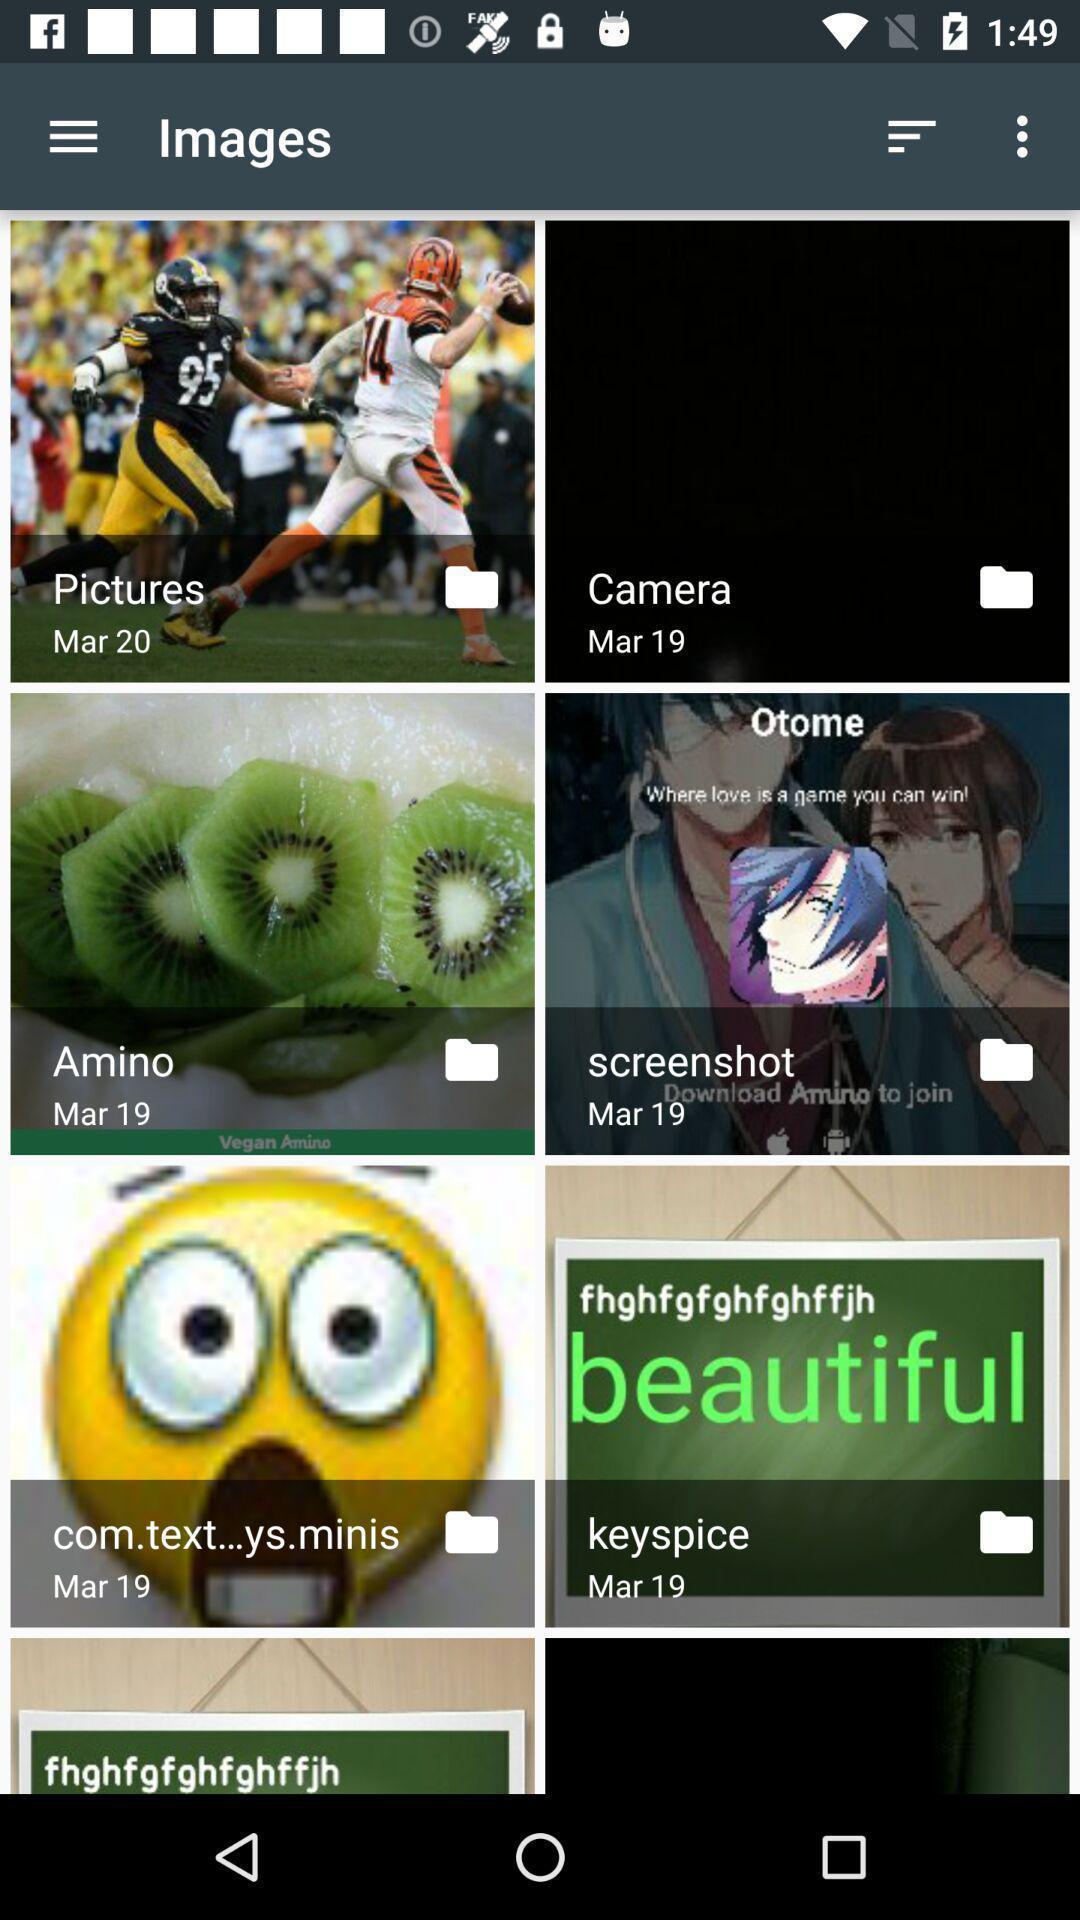Provide a description of this screenshot. Page showing various folders of images. 